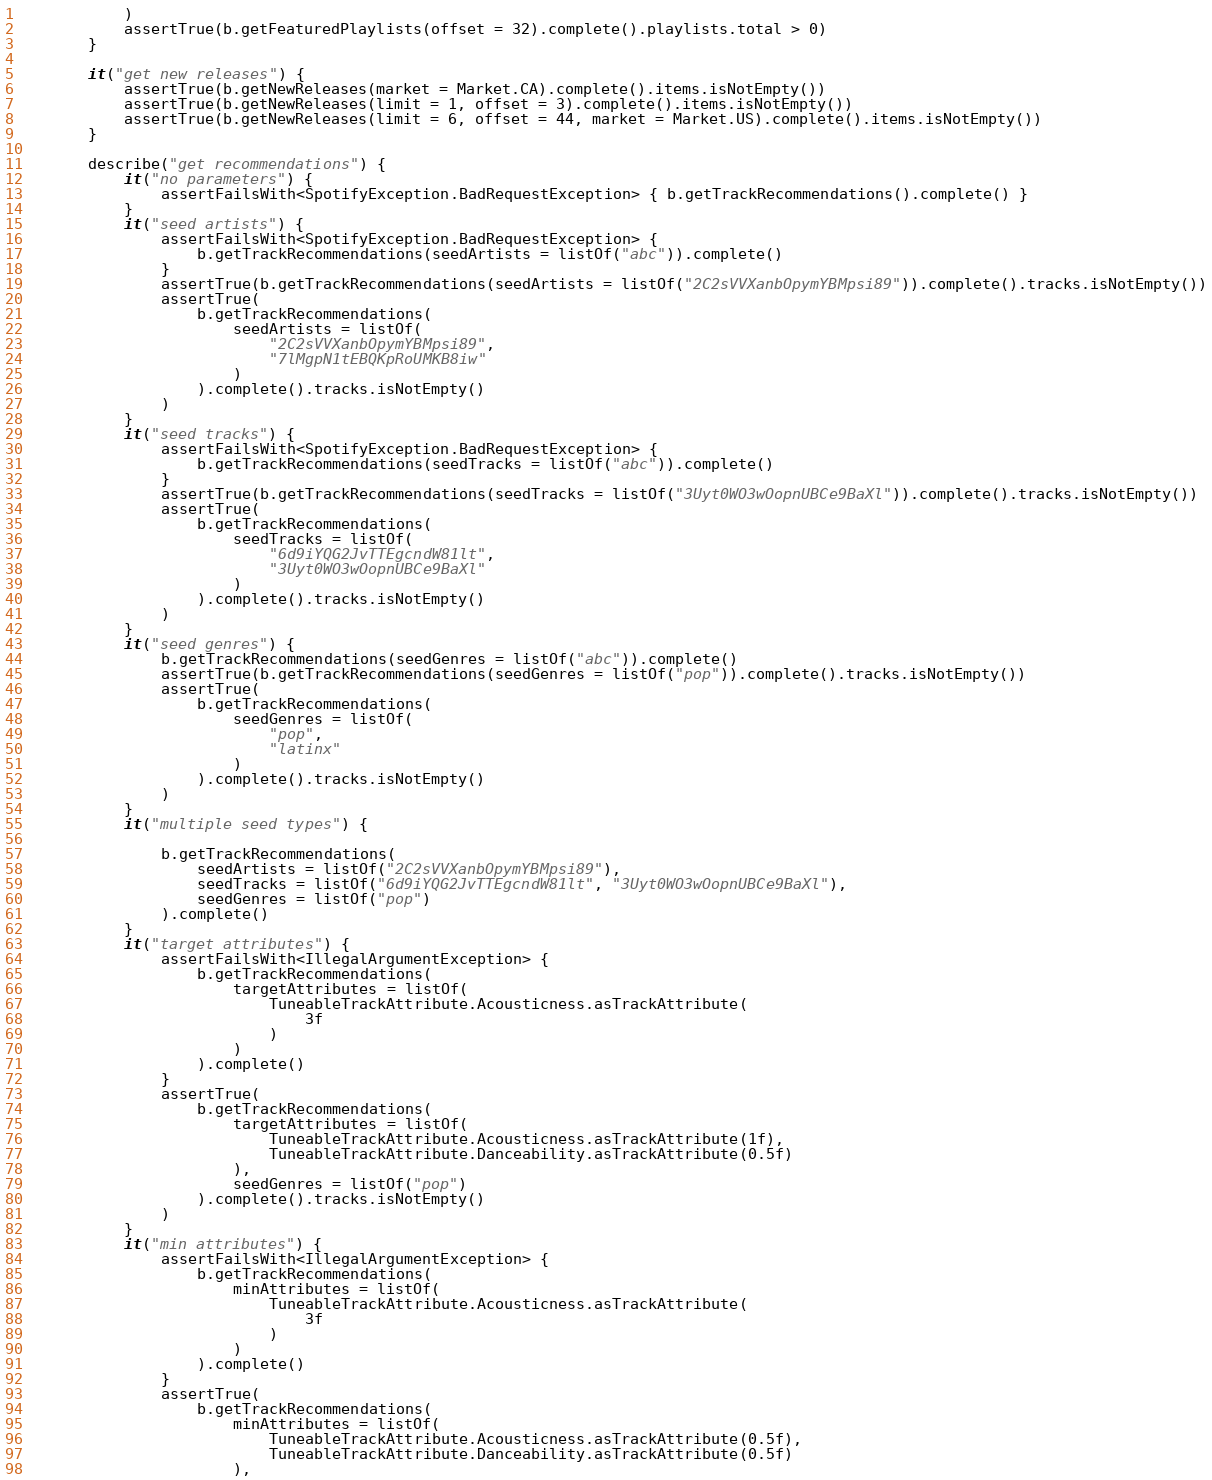<code> <loc_0><loc_0><loc_500><loc_500><_Kotlin_>            )
            assertTrue(b.getFeaturedPlaylists(offset = 32).complete().playlists.total > 0)
        }

        it("get new releases") {
            assertTrue(b.getNewReleases(market = Market.CA).complete().items.isNotEmpty())
            assertTrue(b.getNewReleases(limit = 1, offset = 3).complete().items.isNotEmpty())
            assertTrue(b.getNewReleases(limit = 6, offset = 44, market = Market.US).complete().items.isNotEmpty())
        }

        describe("get recommendations") {
            it("no parameters") {
                assertFailsWith<SpotifyException.BadRequestException> { b.getTrackRecommendations().complete() }
            }
            it("seed artists") {
                assertFailsWith<SpotifyException.BadRequestException> {
                    b.getTrackRecommendations(seedArtists = listOf("abc")).complete()
                }
                assertTrue(b.getTrackRecommendations(seedArtists = listOf("2C2sVVXanbOpymYBMpsi89")).complete().tracks.isNotEmpty())
                assertTrue(
                    b.getTrackRecommendations(
                        seedArtists = listOf(
                            "2C2sVVXanbOpymYBMpsi89",
                            "7lMgpN1tEBQKpRoUMKB8iw"
                        )
                    ).complete().tracks.isNotEmpty()
                )
            }
            it("seed tracks") {
                assertFailsWith<SpotifyException.BadRequestException> {
                    b.getTrackRecommendations(seedTracks = listOf("abc")).complete()
                }
                assertTrue(b.getTrackRecommendations(seedTracks = listOf("3Uyt0WO3wOopnUBCe9BaXl")).complete().tracks.isNotEmpty())
                assertTrue(
                    b.getTrackRecommendations(
                        seedTracks = listOf(
                            "6d9iYQG2JvTTEgcndW81lt",
                            "3Uyt0WO3wOopnUBCe9BaXl"
                        )
                    ).complete().tracks.isNotEmpty()
                )
            }
            it("seed genres") {
                b.getTrackRecommendations(seedGenres = listOf("abc")).complete()
                assertTrue(b.getTrackRecommendations(seedGenres = listOf("pop")).complete().tracks.isNotEmpty())
                assertTrue(
                    b.getTrackRecommendations(
                        seedGenres = listOf(
                            "pop",
                            "latinx"
                        )
                    ).complete().tracks.isNotEmpty()
                )
            }
            it("multiple seed types") {

                b.getTrackRecommendations(
                    seedArtists = listOf("2C2sVVXanbOpymYBMpsi89"),
                    seedTracks = listOf("6d9iYQG2JvTTEgcndW81lt", "3Uyt0WO3wOopnUBCe9BaXl"),
                    seedGenres = listOf("pop")
                ).complete()
            }
            it("target attributes") {
                assertFailsWith<IllegalArgumentException> {
                    b.getTrackRecommendations(
                        targetAttributes = listOf(
                            TuneableTrackAttribute.Acousticness.asTrackAttribute(
                                3f
                            )
                        )
                    ).complete()
                }
                assertTrue(
                    b.getTrackRecommendations(
                        targetAttributes = listOf(
                            TuneableTrackAttribute.Acousticness.asTrackAttribute(1f),
                            TuneableTrackAttribute.Danceability.asTrackAttribute(0.5f)
                        ),
                        seedGenres = listOf("pop")
                    ).complete().tracks.isNotEmpty()
                )
            }
            it("min attributes") {
                assertFailsWith<IllegalArgumentException> {
                    b.getTrackRecommendations(
                        minAttributes = listOf(
                            TuneableTrackAttribute.Acousticness.asTrackAttribute(
                                3f
                            )
                        )
                    ).complete()
                }
                assertTrue(
                    b.getTrackRecommendations(
                        minAttributes = listOf(
                            TuneableTrackAttribute.Acousticness.asTrackAttribute(0.5f),
                            TuneableTrackAttribute.Danceability.asTrackAttribute(0.5f)
                        ),</code> 